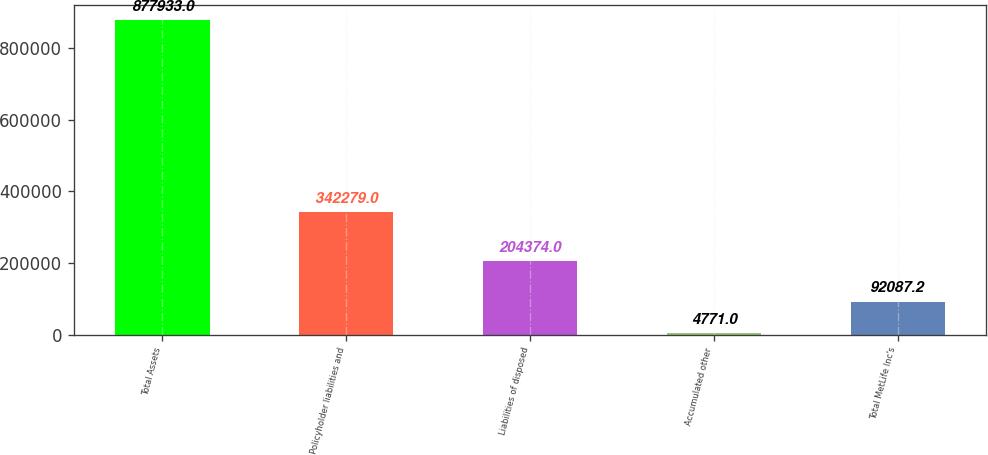Convert chart to OTSL. <chart><loc_0><loc_0><loc_500><loc_500><bar_chart><fcel>Total Assets<fcel>Policyholder liabilities and<fcel>Liabilities of disposed<fcel>Accumulated other<fcel>Total MetLife Inc's<nl><fcel>877933<fcel>342279<fcel>204374<fcel>4771<fcel>92087.2<nl></chart> 